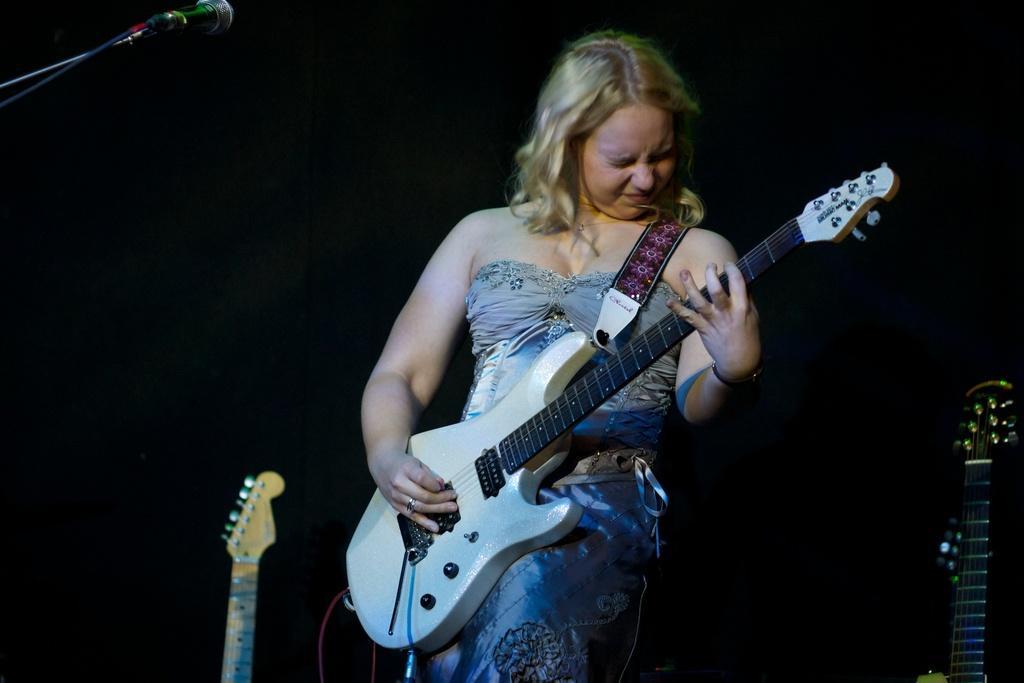Describe this image in one or two sentences. In the center of the image we can see a woman standing and holding a guitar. On the right and left side of the image we can see guitars. At the top left corner we can see mic. 